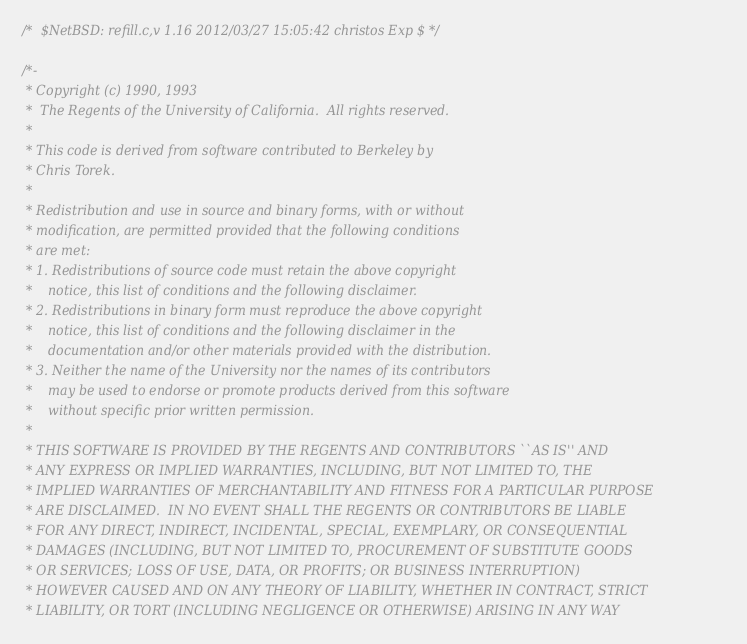Convert code to text. <code><loc_0><loc_0><loc_500><loc_500><_C_>/*	$NetBSD: refill.c,v 1.16 2012/03/27 15:05:42 christos Exp $	*/

/*-
 * Copyright (c) 1990, 1993
 *	The Regents of the University of California.  All rights reserved.
 *
 * This code is derived from software contributed to Berkeley by
 * Chris Torek.
 *
 * Redistribution and use in source and binary forms, with or without
 * modification, are permitted provided that the following conditions
 * are met:
 * 1. Redistributions of source code must retain the above copyright
 *    notice, this list of conditions and the following disclaimer.
 * 2. Redistributions in binary form must reproduce the above copyright
 *    notice, this list of conditions and the following disclaimer in the
 *    documentation and/or other materials provided with the distribution.
 * 3. Neither the name of the University nor the names of its contributors
 *    may be used to endorse or promote products derived from this software
 *    without specific prior written permission.
 *
 * THIS SOFTWARE IS PROVIDED BY THE REGENTS AND CONTRIBUTORS ``AS IS'' AND
 * ANY EXPRESS OR IMPLIED WARRANTIES, INCLUDING, BUT NOT LIMITED TO, THE
 * IMPLIED WARRANTIES OF MERCHANTABILITY AND FITNESS FOR A PARTICULAR PURPOSE
 * ARE DISCLAIMED.  IN NO EVENT SHALL THE REGENTS OR CONTRIBUTORS BE LIABLE
 * FOR ANY DIRECT, INDIRECT, INCIDENTAL, SPECIAL, EXEMPLARY, OR CONSEQUENTIAL
 * DAMAGES (INCLUDING, BUT NOT LIMITED TO, PROCUREMENT OF SUBSTITUTE GOODS
 * OR SERVICES; LOSS OF USE, DATA, OR PROFITS; OR BUSINESS INTERRUPTION)
 * HOWEVER CAUSED AND ON ANY THEORY OF LIABILITY, WHETHER IN CONTRACT, STRICT
 * LIABILITY, OR TORT (INCLUDING NEGLIGENCE OR OTHERWISE) ARISING IN ANY WAY</code> 